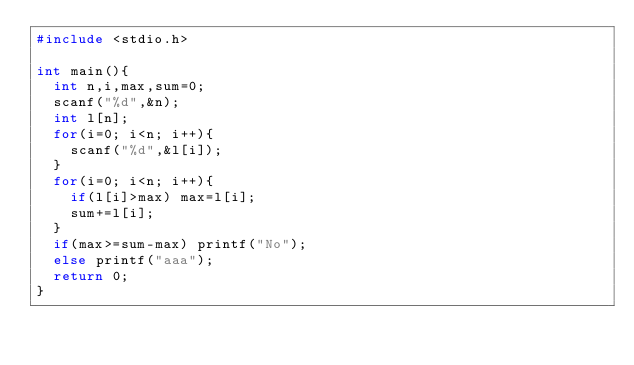<code> <loc_0><loc_0><loc_500><loc_500><_C_>#include <stdio.h>

int main(){
  int n,i,max,sum=0;
  scanf("%d",&n);
  int l[n];
  for(i=0; i<n; i++){
    scanf("%d",&l[i]);
  }
  for(i=0; i<n; i++){
    if(l[i]>max) max=l[i];
    sum+=l[i];
  }
  if(max>=sum-max) printf("No");
  else printf("aaa");
  return 0;
}
</code> 